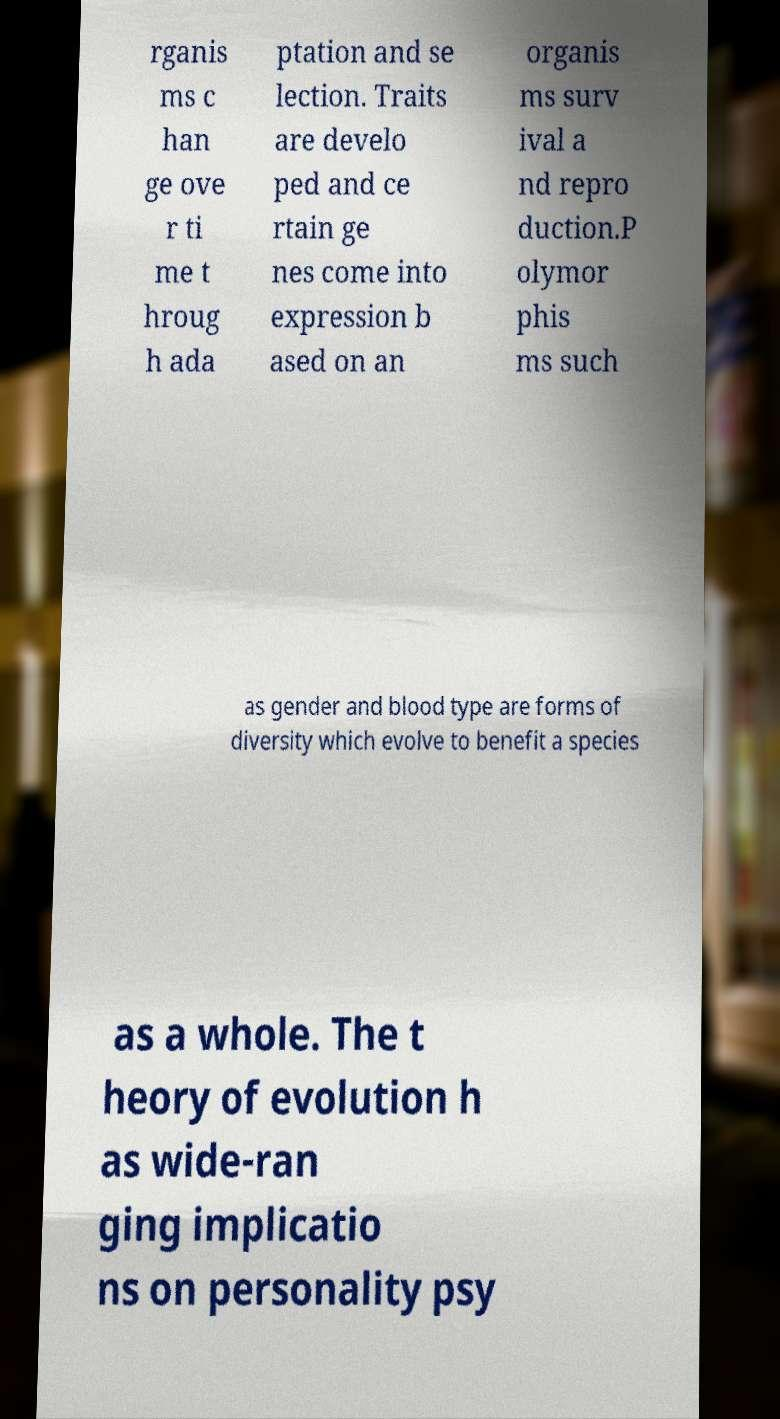Please identify and transcribe the text found in this image. rganis ms c han ge ove r ti me t hroug h ada ptation and se lection. Traits are develo ped and ce rtain ge nes come into expression b ased on an organis ms surv ival a nd repro duction.P olymor phis ms such as gender and blood type are forms of diversity which evolve to benefit a species as a whole. The t heory of evolution h as wide-ran ging implicatio ns on personality psy 